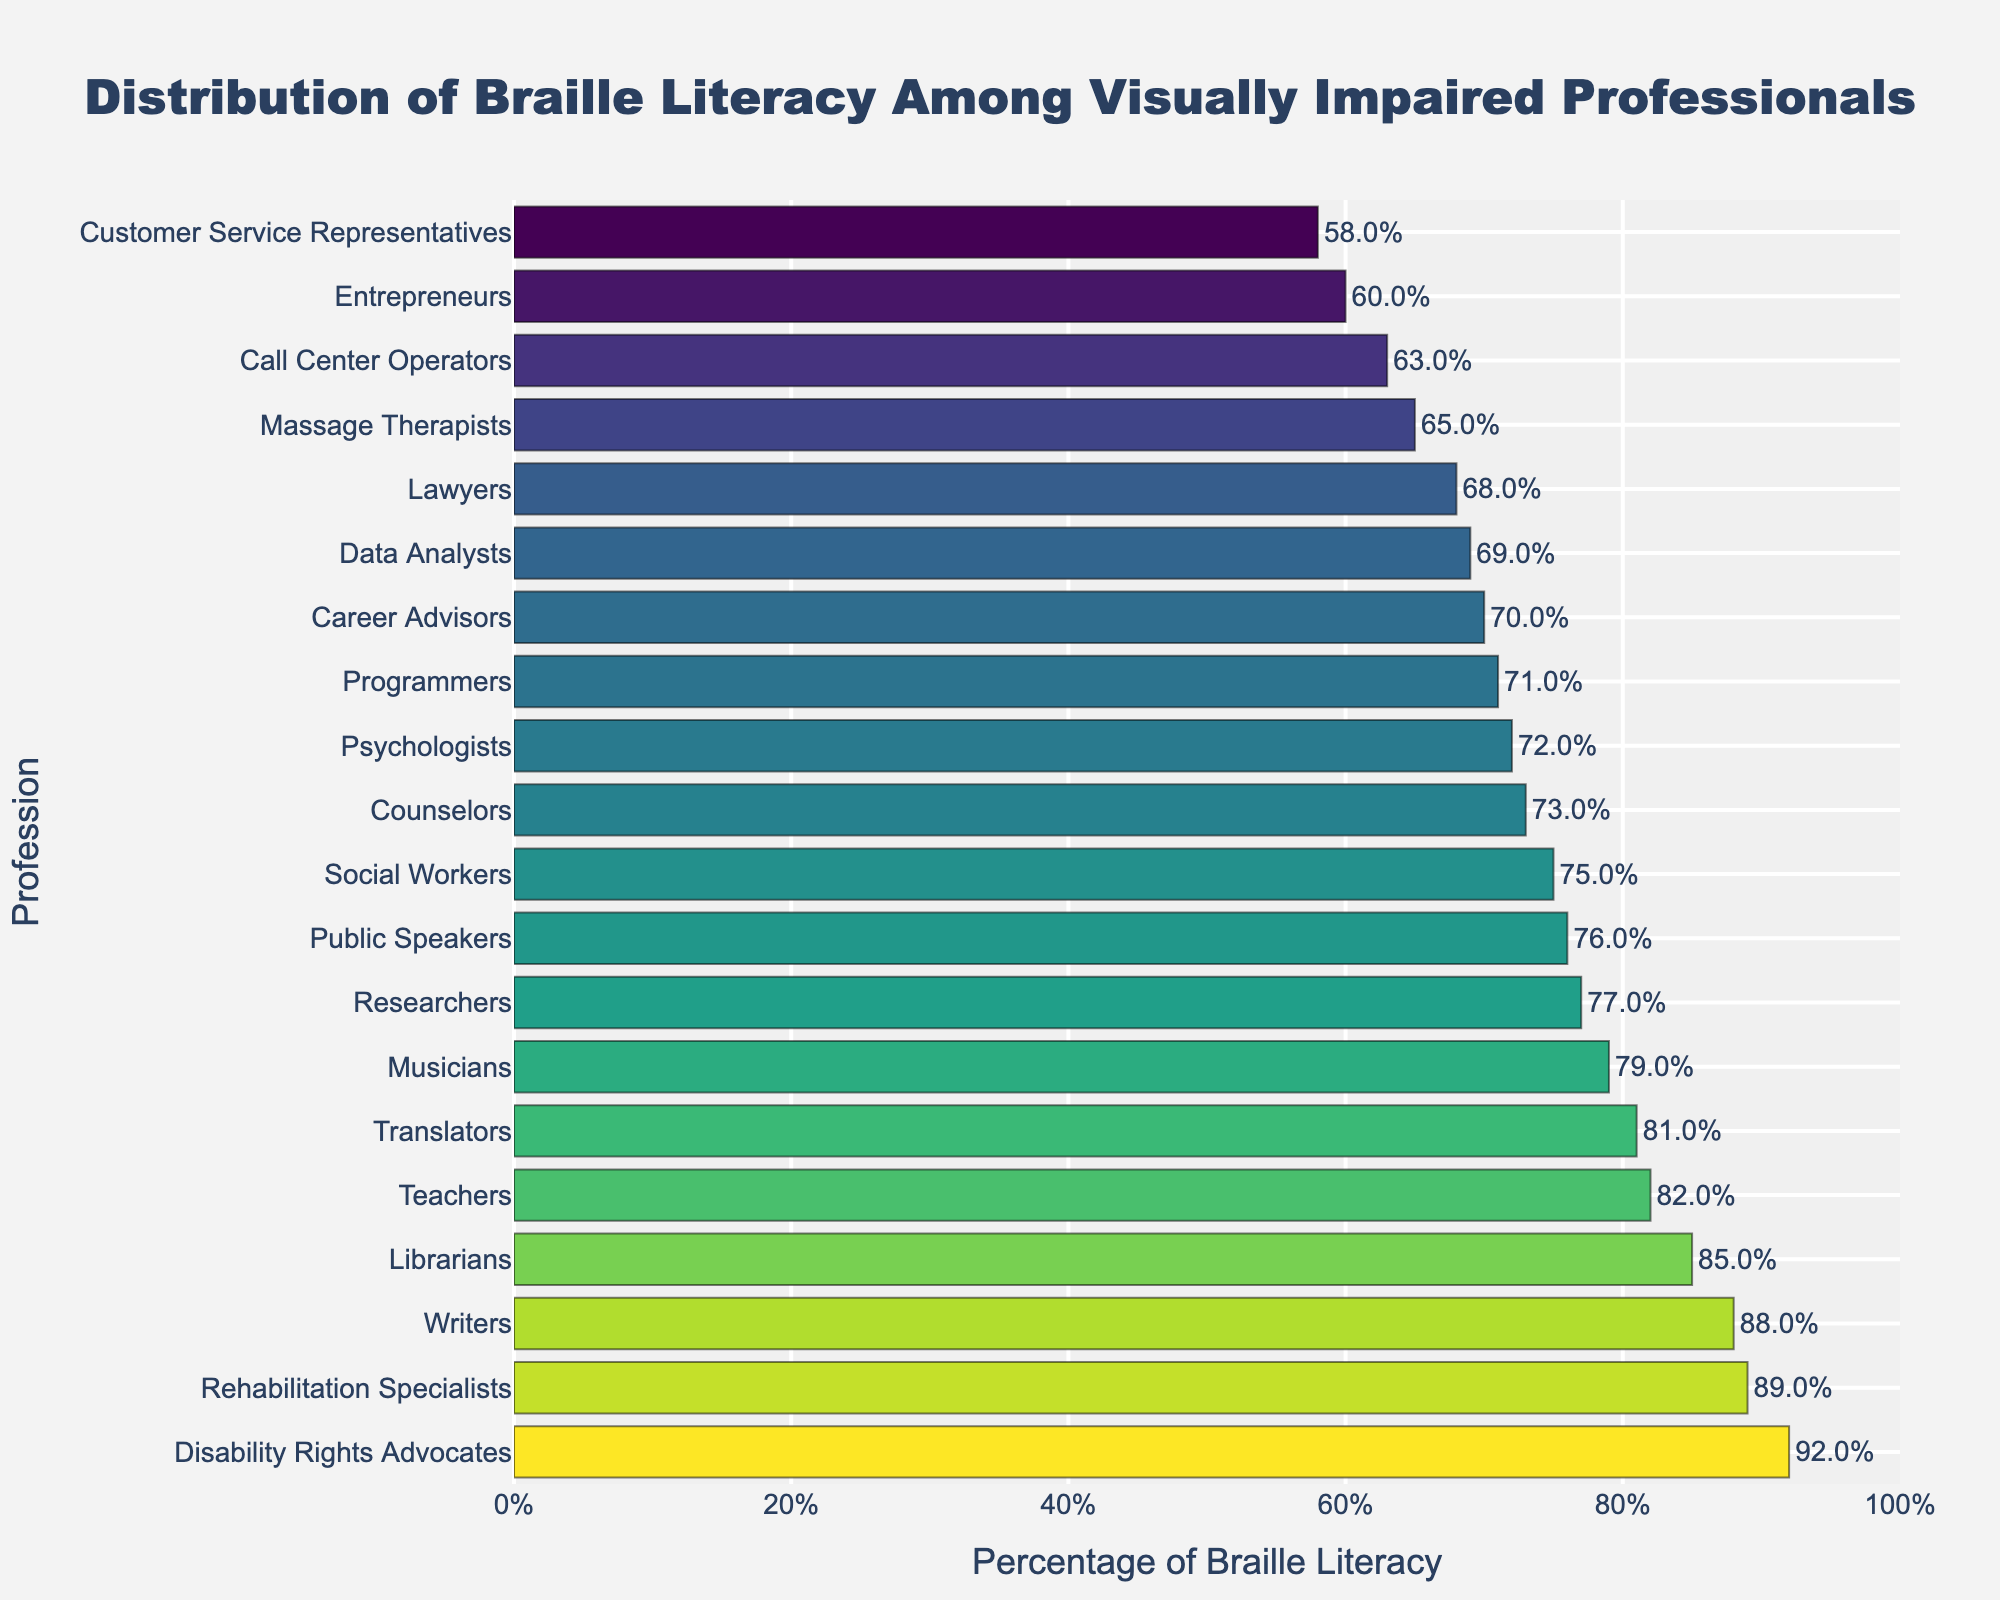What profession has the highest Braille literacy percentage? The highest bar on the graph, which is colored the darkest, represents "Disability Rights Advocates" with a Braille literacy percentage of 92.
Answer: Disability Rights Advocates Which profession has the lowest Braille literacy percentage? The lowest bar on the graph, which is colored the lightest, represents "Customer Service Representatives" with a Braille literacy percentage of 58.
Answer: Customer Service Representatives Compare the Braille literacy percentages of Teachers and Lawyers. Which one is higher? Teachers have a Braille literacy percentage of 82, while Lawyers have 68. Comparing these two, Teachers have a higher percentage.
Answer: Teachers What is the average Braille literacy percentage of Teachers, Lawyers, and Social Workers? To find the average, sum the percentages of Teachers (82), Lawyers (68), and Social Workers (75) and divide by 3: Average = (82 + 68 + 75) / 3 = 225 / 3 = 75.
Answer: 75 How many professions have a Braille literacy percentage higher than 80? By examining the bars with labels at their end values higher than 80, we count 5 professions: Teachers, Writers, Translators, Librarians, and Disability Rights Advocates.
Answer: 5 What is the difference in Braille literacy percentage between the highest and the lowest profession? The highest percentage is 92 (Disability Rights Advocates) and the lowest is 58 (Customer Service Representatives). The difference is 92 - 58 = 34.
Answer: 34 Which profession has a Braille literacy percentage closest to 70? Out of the professions around 70%, Career Advisors (70) is the closest, followed by Psychologists (72) and Data Analysts (69).
Answer: Career Advisors Is there any profession with exactly 75% Braille literacy? The bar corresponding to Social Workers shows exactly 75% Braille literacy.
Answer: Social Workers Identify three professions with a Braille literacy percentage of 75 or more but less than 80. The bars that fit this range are Musicians (79), Researchers (77), and Public Speakers (76).
Answer: Musicians, Researchers, Public Speakers 